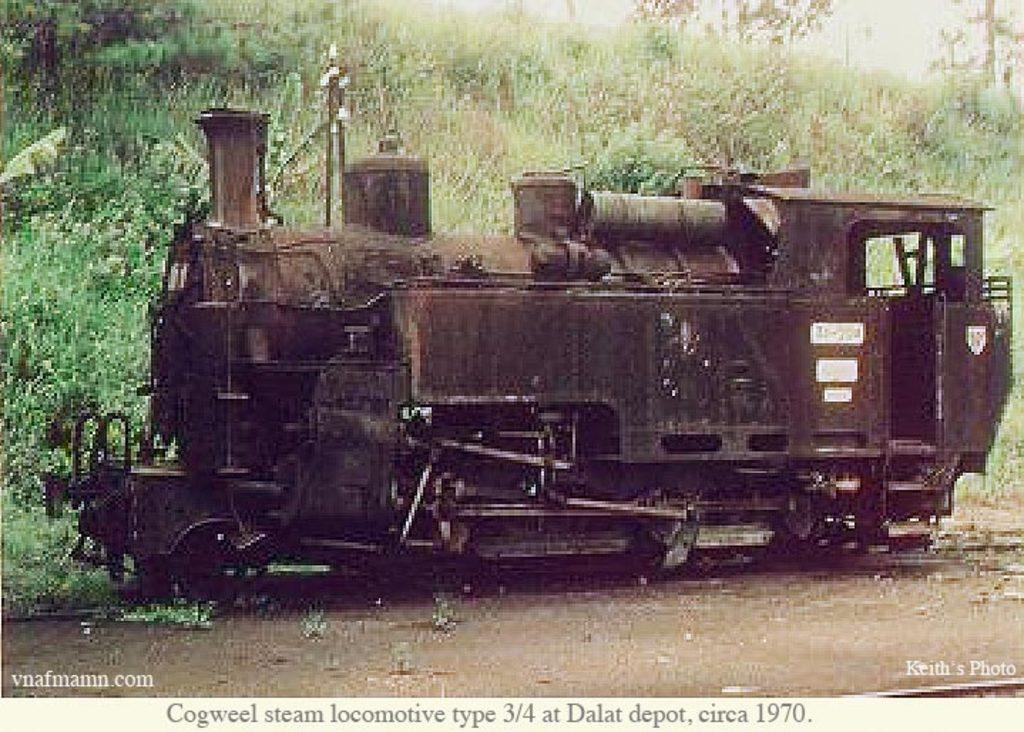What is the main subject of the image? The main subject of the image is a train engine. What can be seen in the background of the image? There are trees and plants in the background of the image. What is the price of the van in the image? There is no van present in the image, so it is not possible to determine its price. What type of bulb is used to light up the train engine in the image? There is no information about lighting or bulbs in the image, so it is not possible to determine the type of bulb used. 